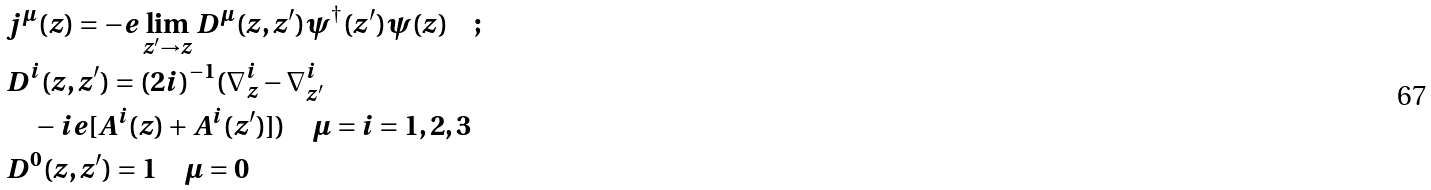Convert formula to latex. <formula><loc_0><loc_0><loc_500><loc_500>& j ^ { \mu } ( z ) = - e \lim _ { z ^ { \prime } \rightarrow z } D ^ { \mu } ( z , z ^ { \prime } ) \psi ^ { \dagger } ( z ^ { \prime } ) \psi ( z ) \quad ; \\ & D ^ { i } ( z , z ^ { \prime } ) = ( 2 i ) ^ { - 1 } ( \nabla ^ { i } _ { z } - \nabla ^ { i } _ { z ^ { \prime } } \\ & \quad - i e [ A ^ { i } ( z ) + A ^ { i } ( z ^ { \prime } ) ] ) \quad \mu = i = 1 , 2 , 3 \\ & D ^ { 0 } ( z , z ^ { \prime } ) = 1 \quad \mu = 0</formula> 